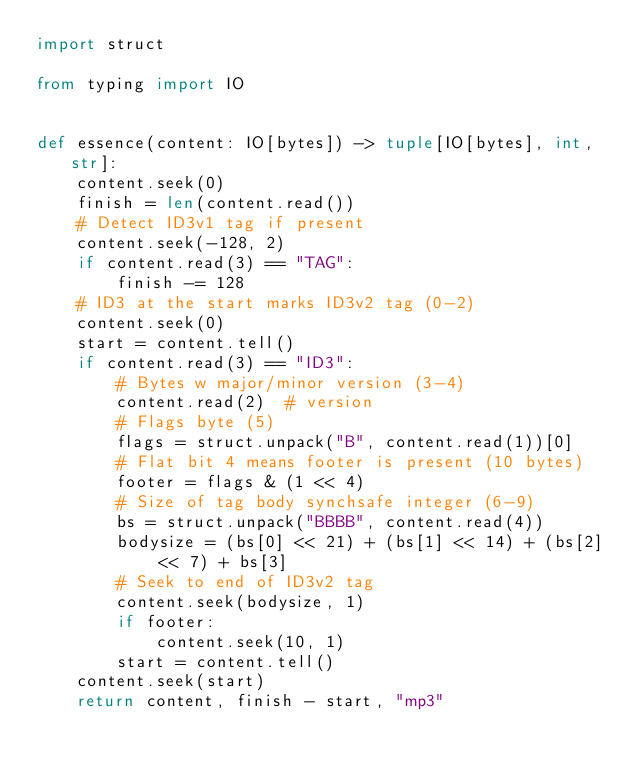Convert code to text. <code><loc_0><loc_0><loc_500><loc_500><_Python_>import struct

from typing import IO


def essence(content: IO[bytes]) -> tuple[IO[bytes], int, str]:
    content.seek(0)
    finish = len(content.read())
    # Detect ID3v1 tag if present
    content.seek(-128, 2)
    if content.read(3) == "TAG":
        finish -= 128
    # ID3 at the start marks ID3v2 tag (0-2)
    content.seek(0)
    start = content.tell()
    if content.read(3) == "ID3":
        # Bytes w major/minor version (3-4)
        content.read(2)  # version
        # Flags byte (5)
        flags = struct.unpack("B", content.read(1))[0]
        # Flat bit 4 means footer is present (10 bytes)
        footer = flags & (1 << 4)
        # Size of tag body synchsafe integer (6-9)
        bs = struct.unpack("BBBB", content.read(4))
        bodysize = (bs[0] << 21) + (bs[1] << 14) + (bs[2] << 7) + bs[3]
        # Seek to end of ID3v2 tag
        content.seek(bodysize, 1)
        if footer:
            content.seek(10, 1)
        start = content.tell()
    content.seek(start)
    return content, finish - start, "mp3"
</code> 